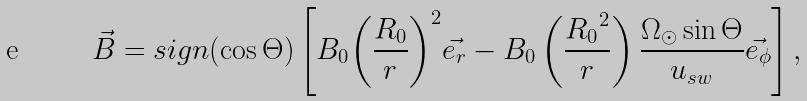Convert formula to latex. <formula><loc_0><loc_0><loc_500><loc_500>\vec { B } = s i g n ( \cos \Theta ) \left [ B _ { 0 } { \left ( \frac { R _ { 0 } } { r } \right ) } ^ { 2 } \vec { e _ { r } } - B _ { 0 } \left ( \frac { { R _ { 0 } } ^ { 2 } } { r } \right ) \frac { \Omega _ { \odot } \sin \Theta } { u _ { s w } } \vec { e _ { \phi } } \right ] ,</formula> 